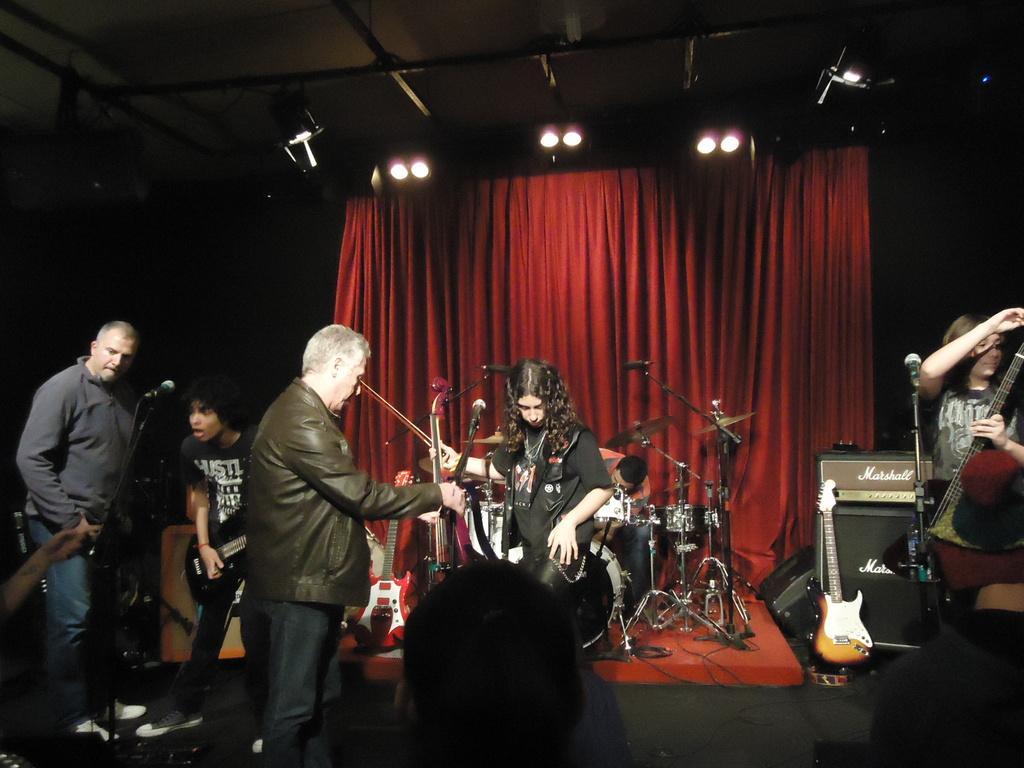Can you describe this image briefly? This Image is clicked in a musical concert. There are lights on the top, there is a curtain in the back side which is in maroon color. There are so many people in this image. All of them are playing musical instruments. There are mikes in front of them, behind them there are drums. There is a person who is playing drums. 